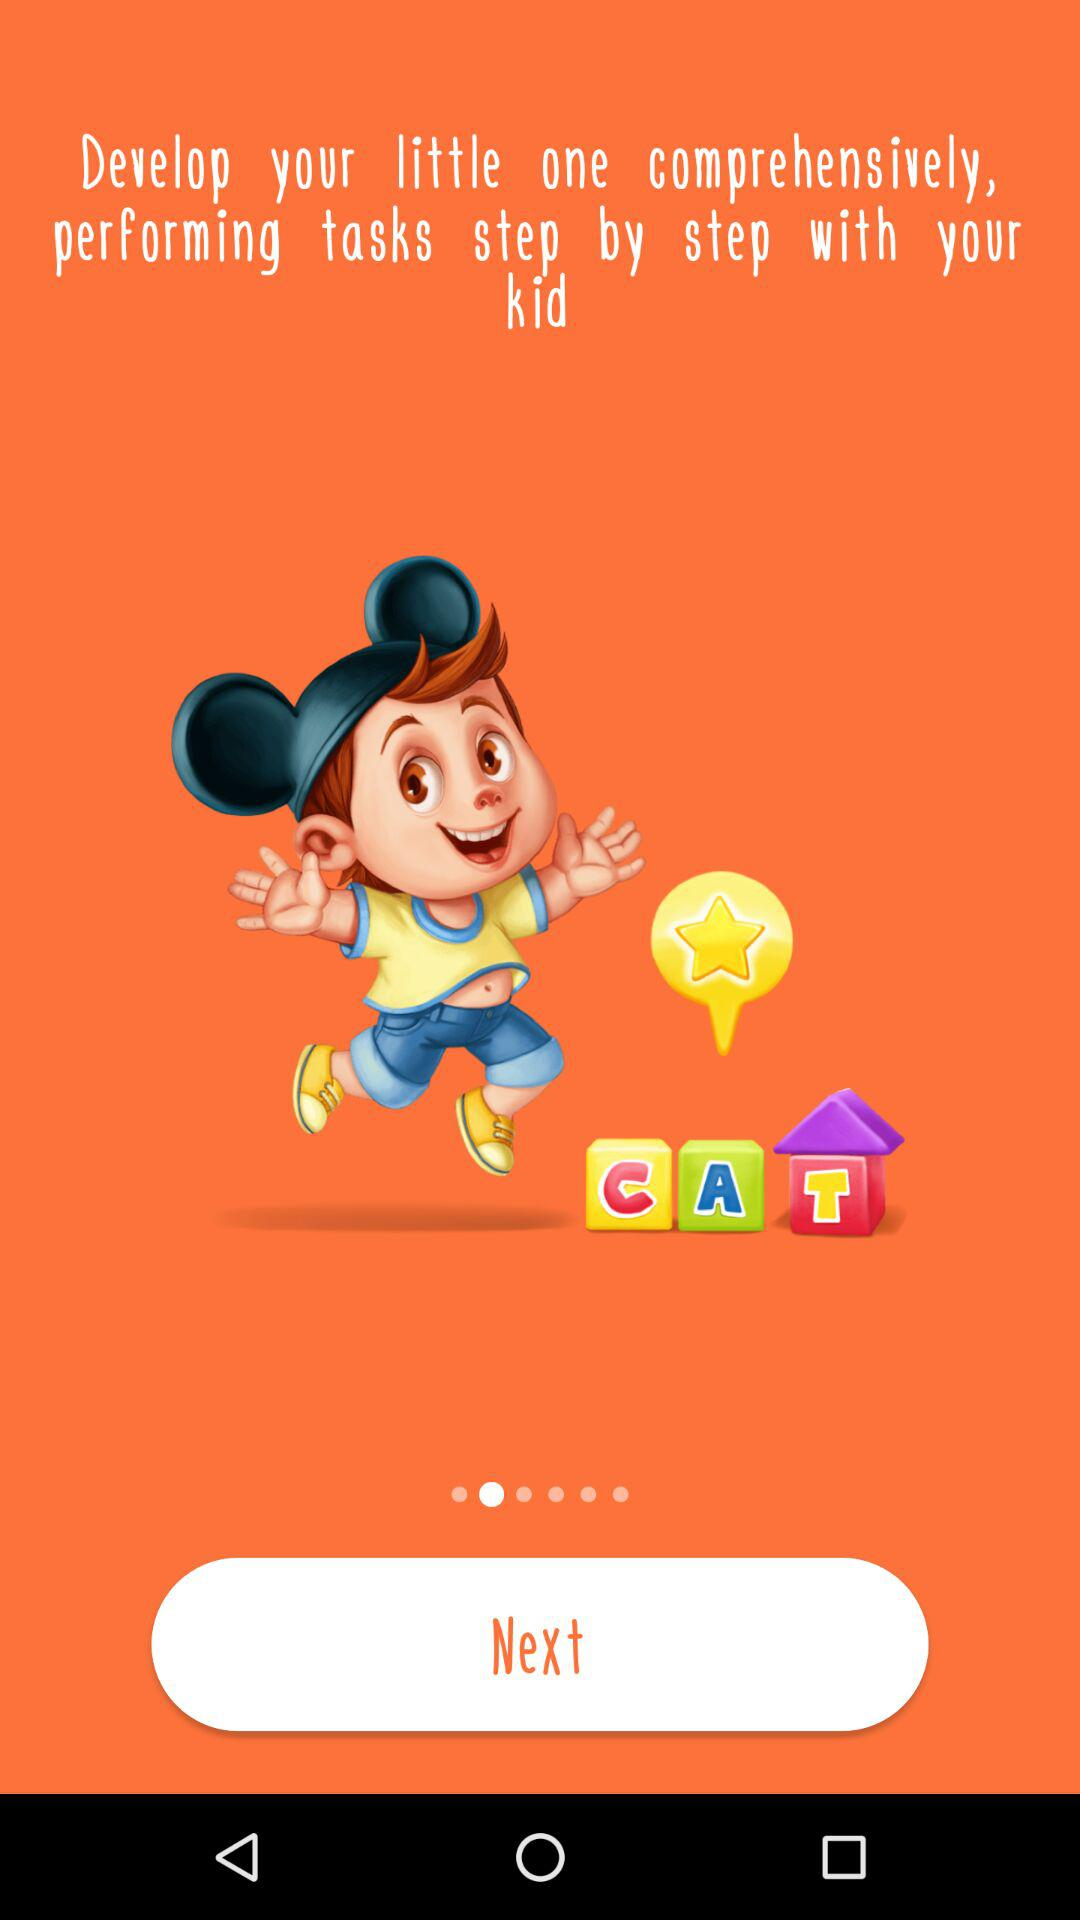What do we need to do to develop our little ones comprehensively? You need to perform tasks step by step with your kid to develop your little ones comprehensively. 